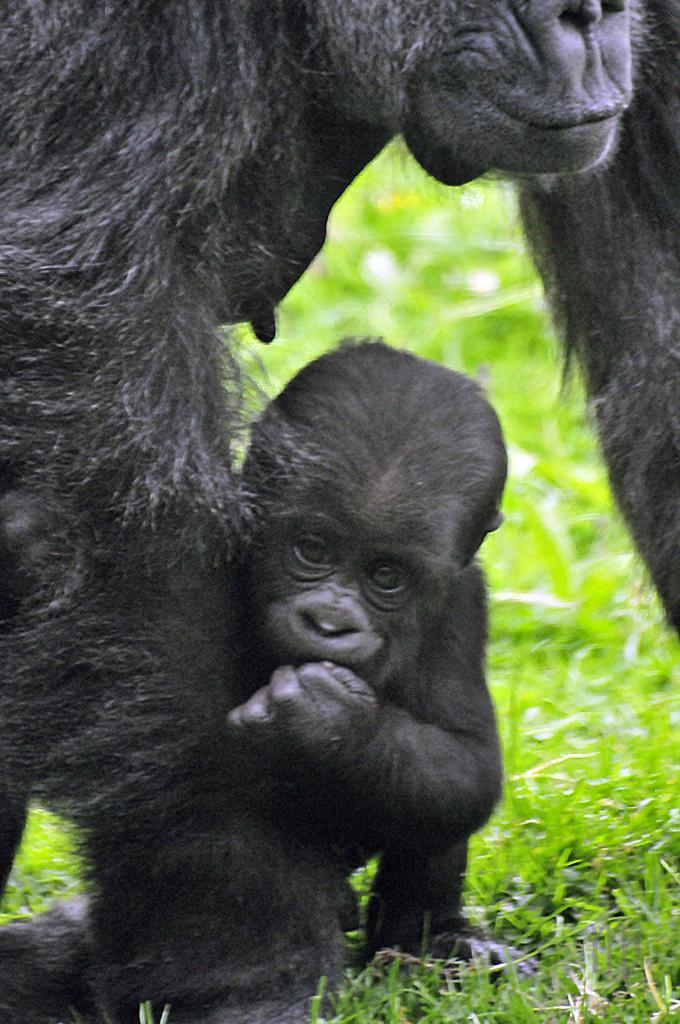How many animals are present in the image? There are two animals in the image. What color are the animals? The animals are black in color. What can be seen in the background of the image? There is grass visible in the background of the image. What type of attention is the animal giving in the image? There is no indication in the image that the animals are giving any type of attention. 